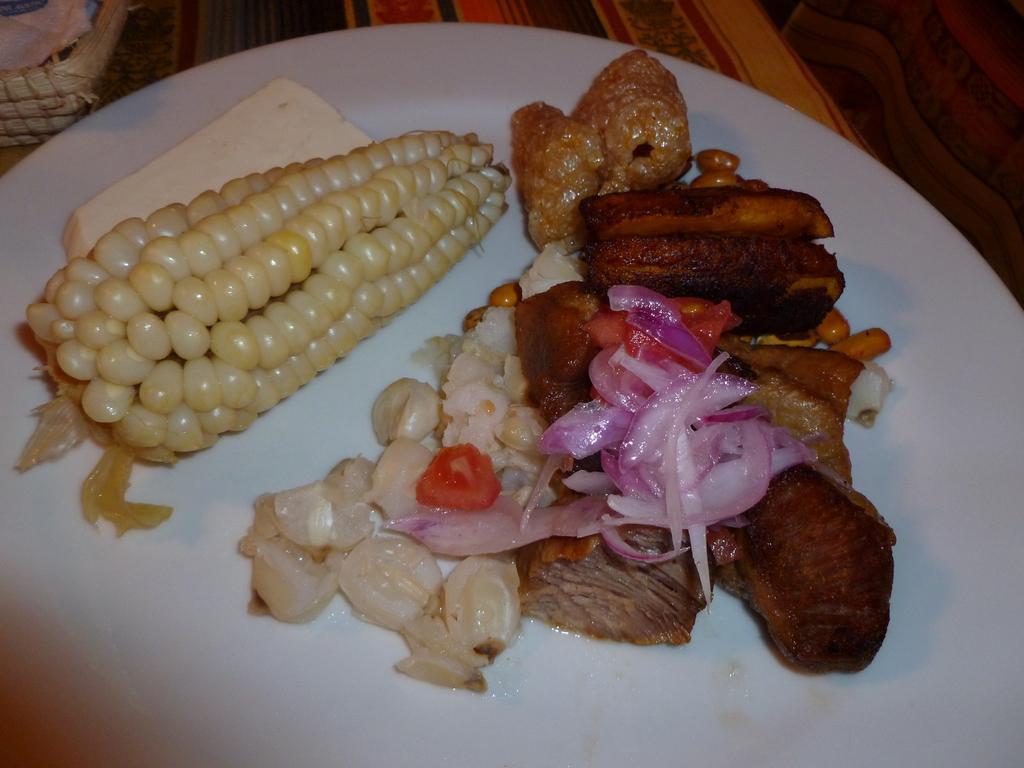Could you give a brief overview of what you see in this image? In this picture I can see food items on the plate, and in the background there are some objects. 